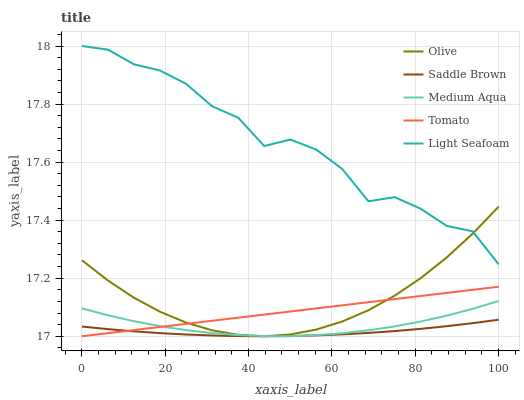Does Saddle Brown have the minimum area under the curve?
Answer yes or no. Yes. Does Light Seafoam have the maximum area under the curve?
Answer yes or no. Yes. Does Tomato have the minimum area under the curve?
Answer yes or no. No. Does Tomato have the maximum area under the curve?
Answer yes or no. No. Is Tomato the smoothest?
Answer yes or no. Yes. Is Light Seafoam the roughest?
Answer yes or no. Yes. Is Light Seafoam the smoothest?
Answer yes or no. No. Is Tomato the roughest?
Answer yes or no. No. Does Light Seafoam have the lowest value?
Answer yes or no. No. Does Light Seafoam have the highest value?
Answer yes or no. Yes. Does Tomato have the highest value?
Answer yes or no. No. Is Tomato less than Light Seafoam?
Answer yes or no. Yes. Is Light Seafoam greater than Saddle Brown?
Answer yes or no. Yes. Does Olive intersect Tomato?
Answer yes or no. Yes. Is Olive less than Tomato?
Answer yes or no. No. Is Olive greater than Tomato?
Answer yes or no. No. Does Tomato intersect Light Seafoam?
Answer yes or no. No. 